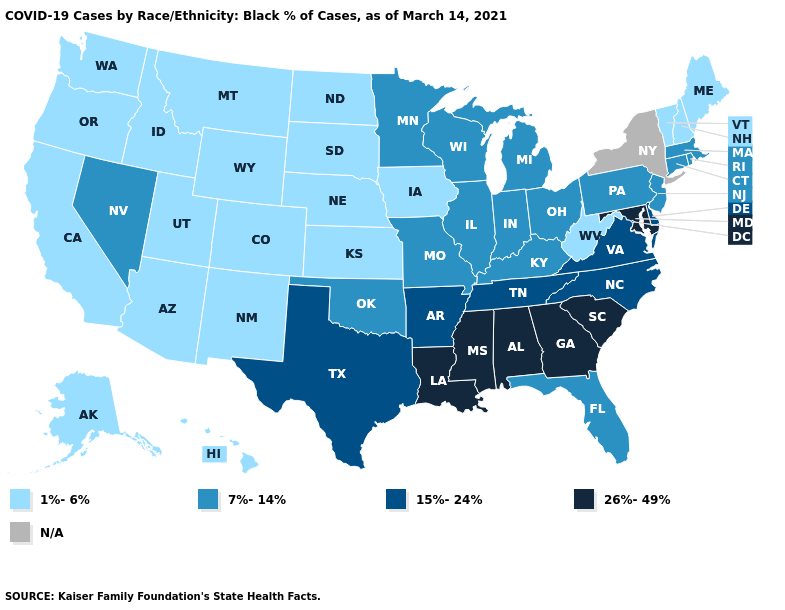What is the lowest value in the Northeast?
Concise answer only. 1%-6%. Does the map have missing data?
Short answer required. Yes. Name the states that have a value in the range 26%-49%?
Concise answer only. Alabama, Georgia, Louisiana, Maryland, Mississippi, South Carolina. Name the states that have a value in the range 7%-14%?
Concise answer only. Connecticut, Florida, Illinois, Indiana, Kentucky, Massachusetts, Michigan, Minnesota, Missouri, Nevada, New Jersey, Ohio, Oklahoma, Pennsylvania, Rhode Island, Wisconsin. Name the states that have a value in the range 15%-24%?
Concise answer only. Arkansas, Delaware, North Carolina, Tennessee, Texas, Virginia. Name the states that have a value in the range 15%-24%?
Give a very brief answer. Arkansas, Delaware, North Carolina, Tennessee, Texas, Virginia. What is the value of Indiana?
Short answer required. 7%-14%. What is the value of Hawaii?
Answer briefly. 1%-6%. Does the first symbol in the legend represent the smallest category?
Be succinct. Yes. Name the states that have a value in the range 15%-24%?
Keep it brief. Arkansas, Delaware, North Carolina, Tennessee, Texas, Virginia. Name the states that have a value in the range 1%-6%?
Write a very short answer. Alaska, Arizona, California, Colorado, Hawaii, Idaho, Iowa, Kansas, Maine, Montana, Nebraska, New Hampshire, New Mexico, North Dakota, Oregon, South Dakota, Utah, Vermont, Washington, West Virginia, Wyoming. What is the value of Wisconsin?
Keep it brief. 7%-14%. What is the lowest value in the USA?
Answer briefly. 1%-6%. Does New Mexico have the highest value in the West?
Give a very brief answer. No. 